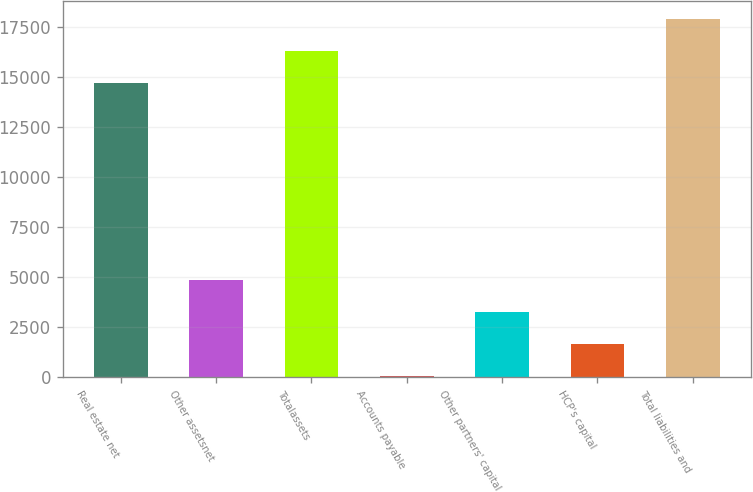Convert chart. <chart><loc_0><loc_0><loc_500><loc_500><bar_chart><fcel>Real estate net<fcel>Other assetsnet<fcel>Totalassets<fcel>Accounts payable<fcel>Other partners' capital<fcel>HCP's capital<fcel>Total liabilities and<nl><fcel>14708<fcel>4873<fcel>16314<fcel>55<fcel>3267<fcel>1661<fcel>17920<nl></chart> 